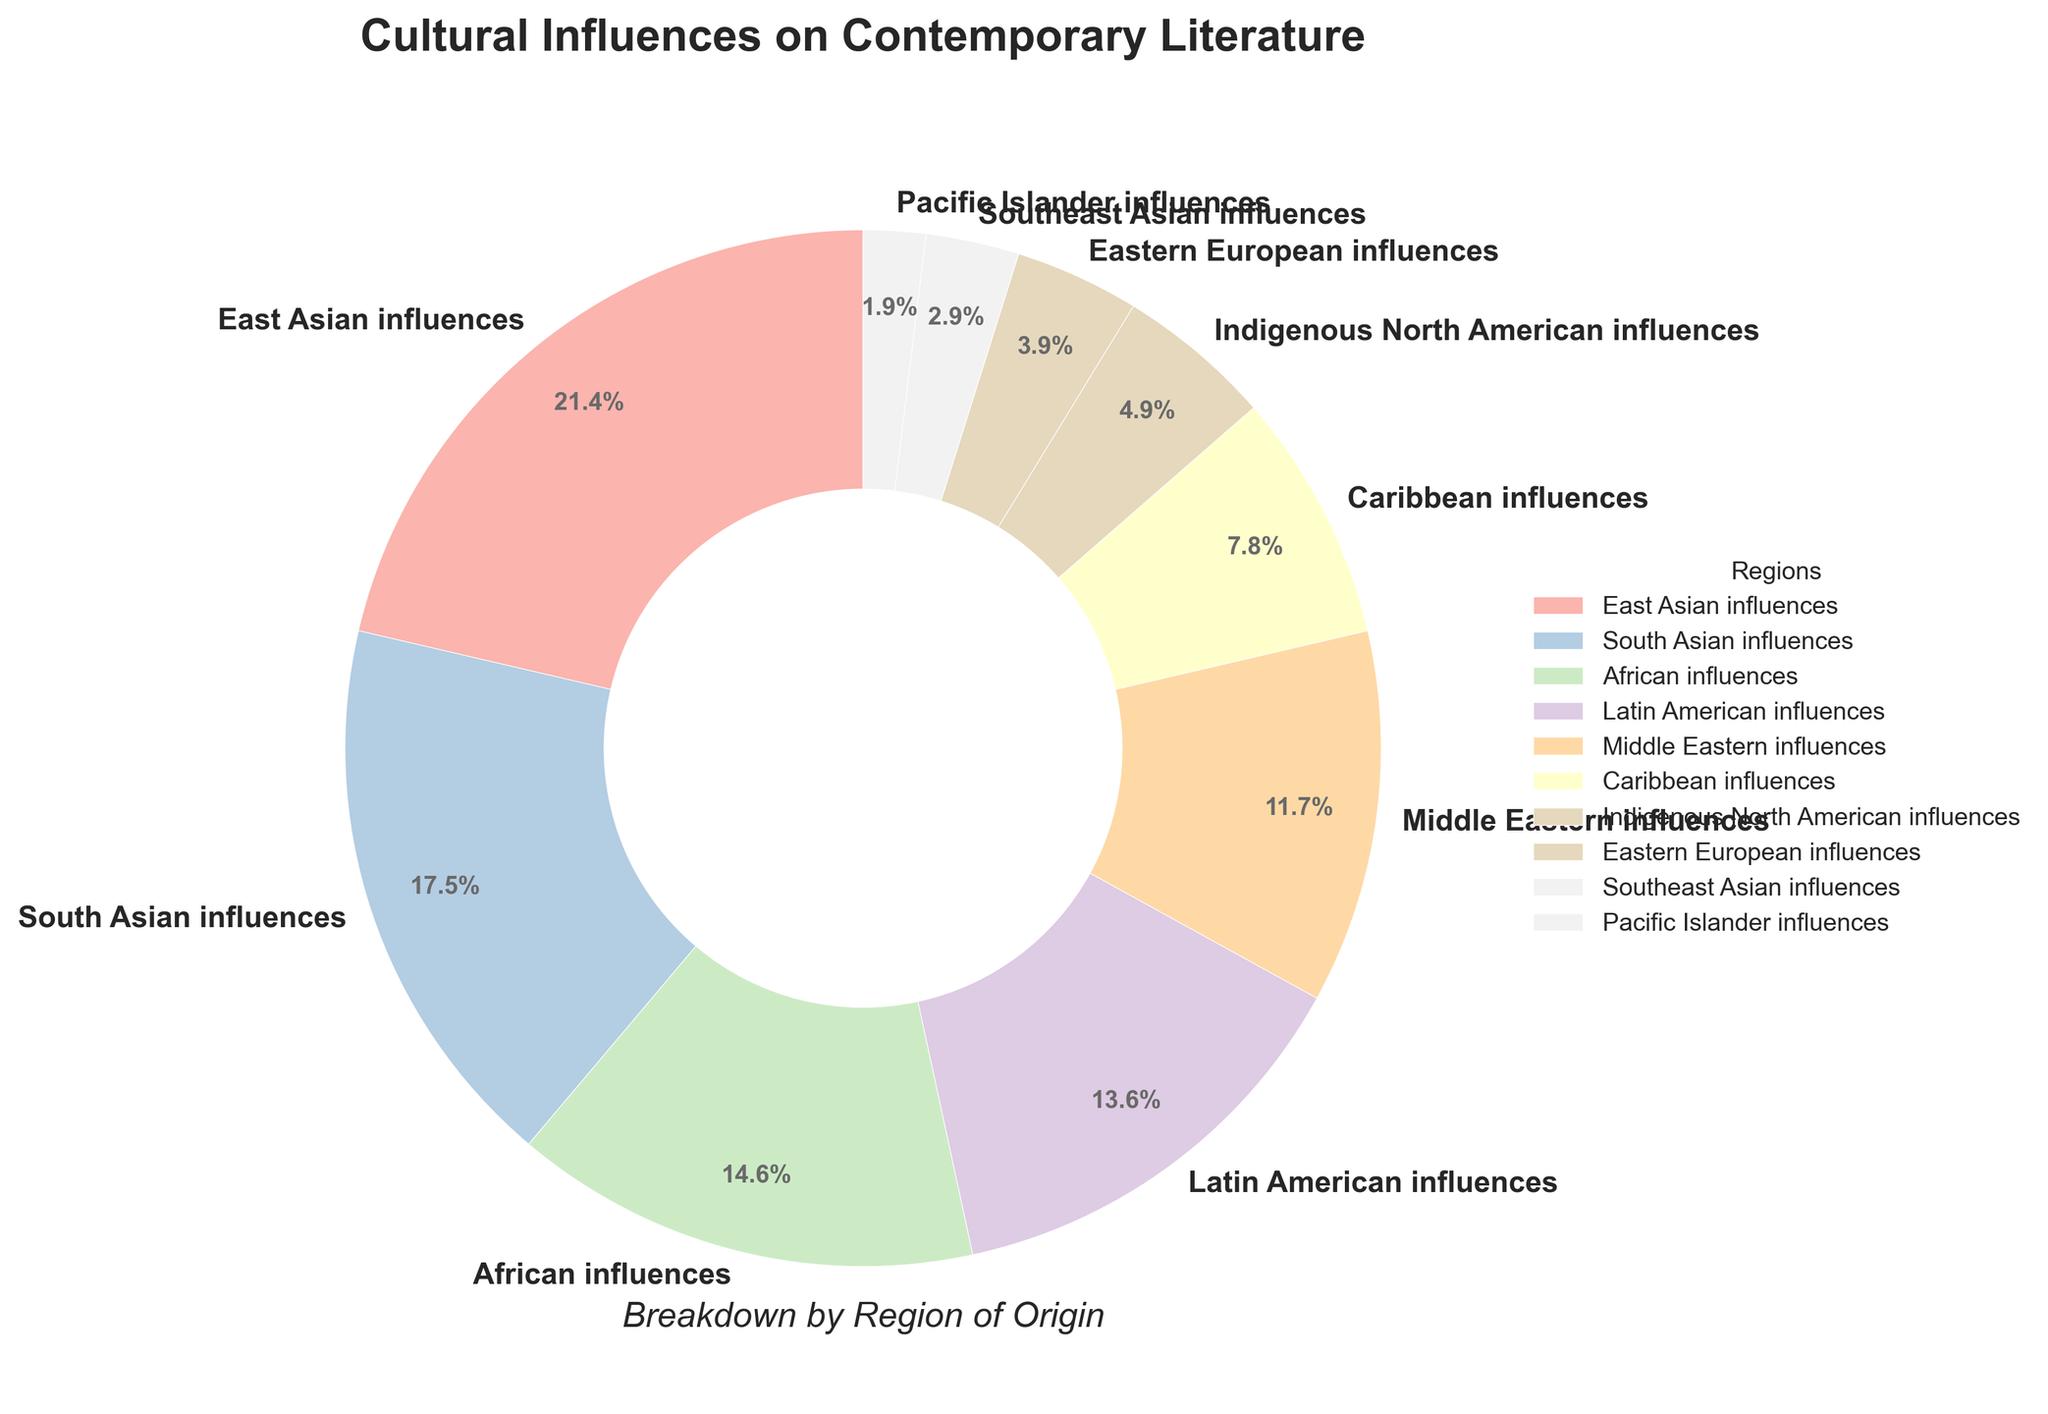What region has the highest cultural influence on contemporary literature according to the chart? The region with the largest percentage segment in the pie chart would have the highest cultural influence. East Asian influences have the highest percentage of 22%.
Answer: East Asian influences What is the total percentage of influences from South Asian and African origins? The total percentage is obtained by adding the percentages of South Asian influences (18%) and African influences (15%). Thus, 18% + 15% = 33%.
Answer: 33% Which region has a lower cultural influence on contemporary literature: Caribbean or Eastern European influences? By comparing the percentages, Caribbean influences have 8%, while Eastern European influences have 4%. Thus, Eastern European influences have a lower cultural influence.
Answer: Eastern European influences How much more influential are East Asian influences compared to Latin American influences? Subtract the percentage of Latin American influences (14%) from the percentage of East Asian influences (22%). Thus, 22% - 14% = 8%.
Answer: 8% Which regions have a combined influence of over 30%? Adding the percentages of East Asian influences (22%) and South Asian influences (18%) yields a combined total of 40%, which is over 30%. These are the regions with a combined influence exceeding 30%.
Answer: East Asian and South Asian influences What is the visual characteristic of the segment with the smallest cultural influence? The smallest percentage segment in the pie chart is for Pacific Islander influences, which is at 2%. This segment is visually the smallest wedge in the chart.
Answer: Pacific Islander influences If we combine Indigenous North American influences and Southeast Asian influences, what is their total contribution? Adding the percentages of Indigenous North American influences (5%) and Southeast Asian influences (3%) results in 5% + 3% = 8%.
Answer: 8% By how much do Middle Eastern influences exceed Pacific Islander influences? The difference between Middle Eastern influences (12%) and Pacific Islander influences (2%) is calculated as 12% - 2% = 10%.
Answer: 10% Which region's influence is exactly twice that of Indigenous North American influences? Indigenous North American influences have a percentage of 5%. The region with double this percentage is Caribbean influences at 8% (which is not exactly double but closest in comparison).
Answer: Caribbean influences 